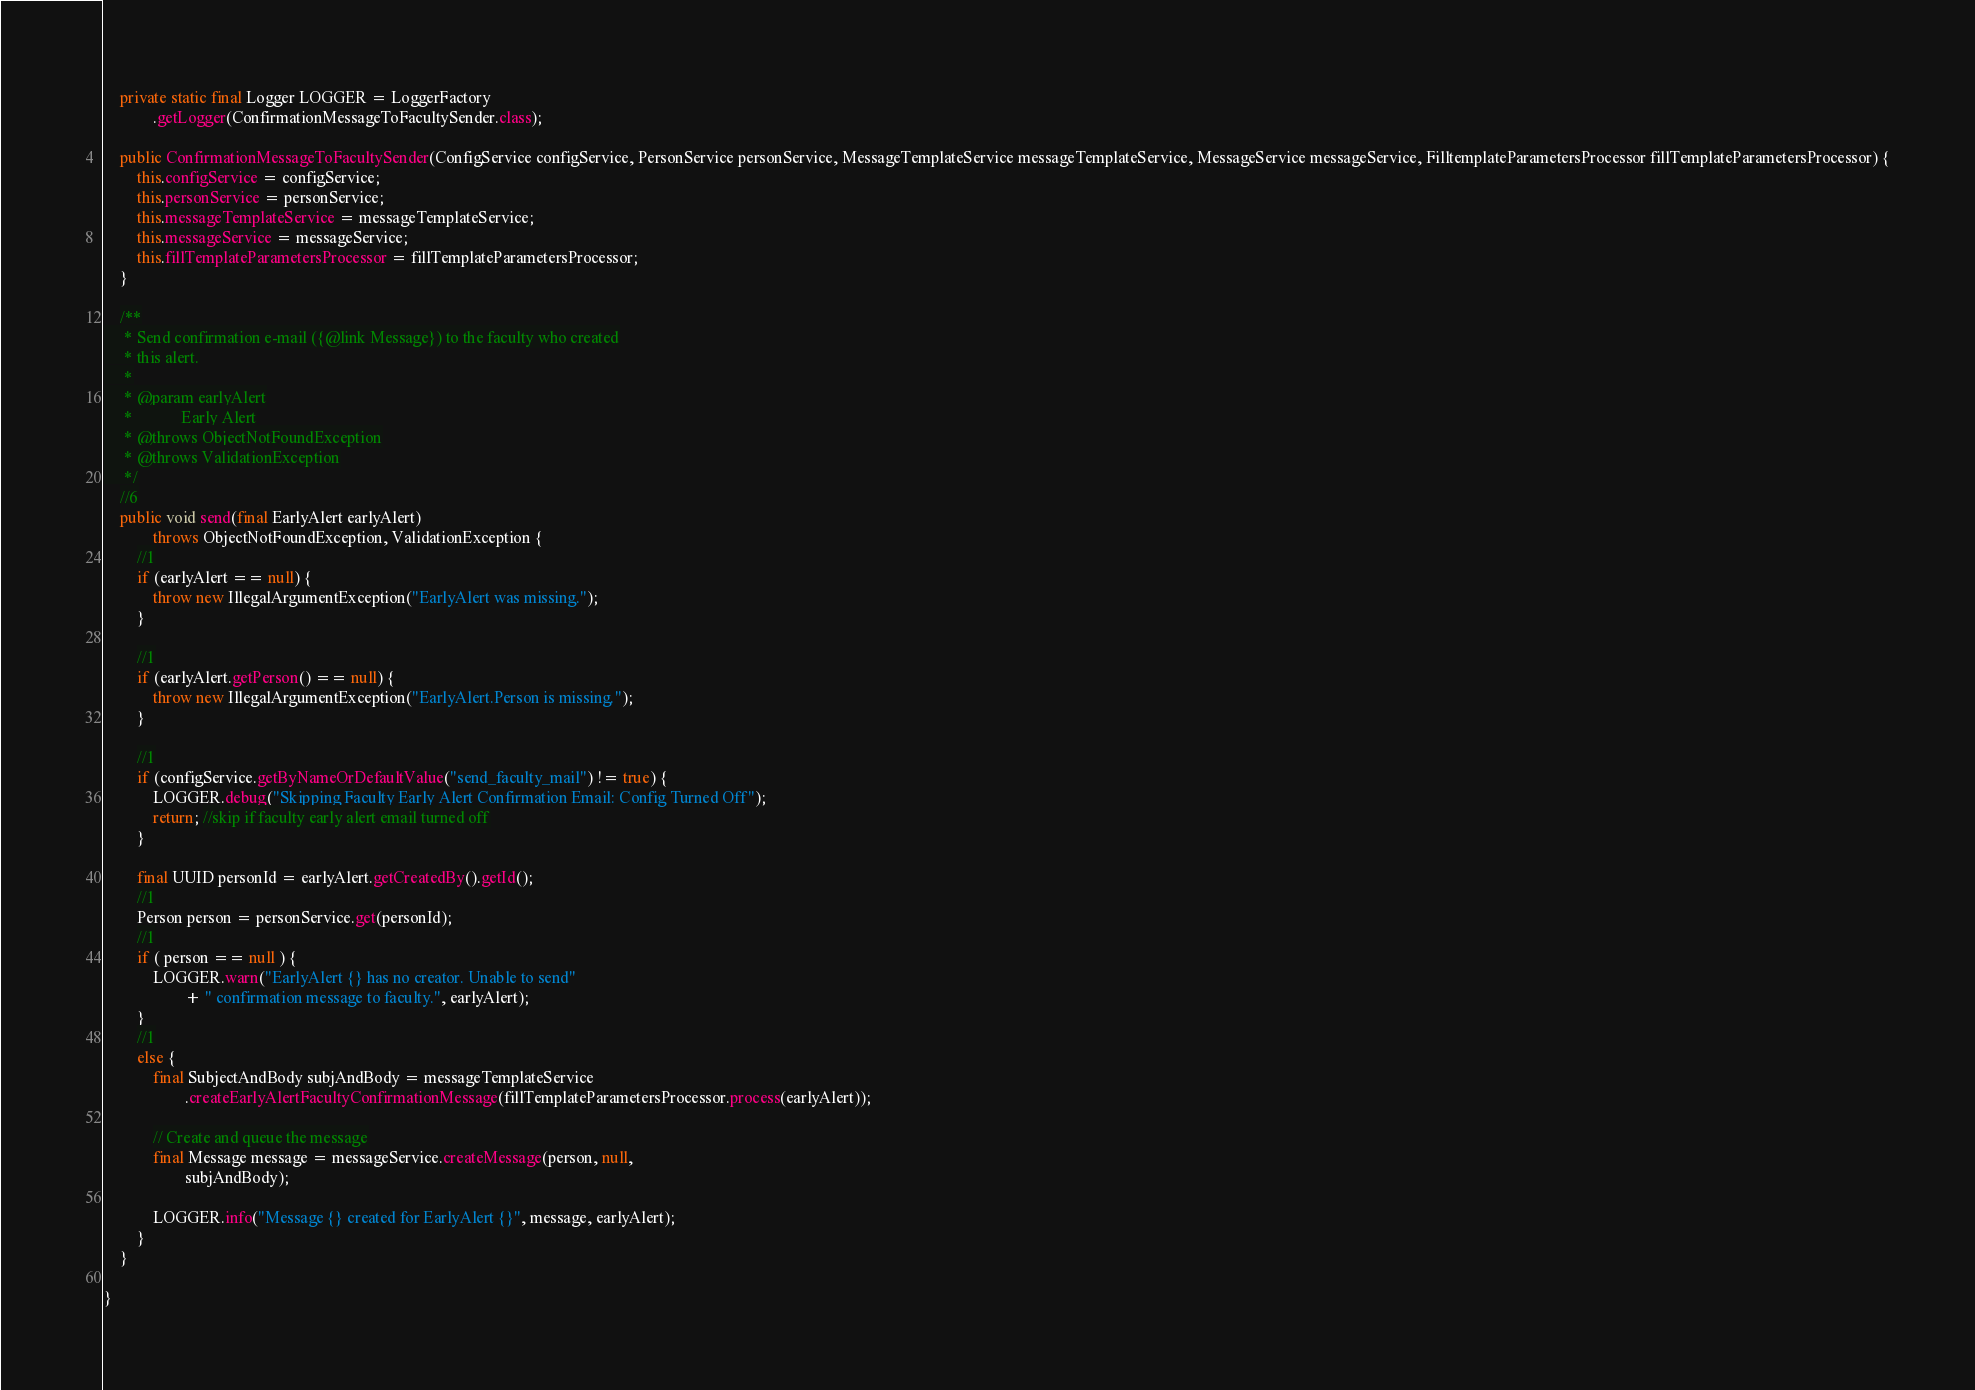Convert code to text. <code><loc_0><loc_0><loc_500><loc_500><_Java_>
    private static final Logger LOGGER = LoggerFactory
            .getLogger(ConfirmationMessageToFacultySender.class);

    public ConfirmationMessageToFacultySender(ConfigService configService, PersonService personService, MessageTemplateService messageTemplateService, MessageService messageService, FilltemplateParametersProcessor fillTemplateParametersProcessor) {
        this.configService = configService;
        this.personService = personService;
        this.messageTemplateService = messageTemplateService;
        this.messageService = messageService;
        this.fillTemplateParametersProcessor = fillTemplateParametersProcessor;
    }

    /**
     * Send confirmation e-mail ({@link Message}) to the faculty who created
     * this alert.
     *
     * @param earlyAlert
     *            Early Alert
     * @throws ObjectNotFoundException
     * @throws ValidationException
     */
    //6
    public void send(final EarlyAlert earlyAlert)
            throws ObjectNotFoundException, ValidationException {
        //1
        if (earlyAlert == null) {
            throw new IllegalArgumentException("EarlyAlert was missing.");
        }

        //1
        if (earlyAlert.getPerson() == null) {
            throw new IllegalArgumentException("EarlyAlert.Person is missing.");
        }

        //1
        if (configService.getByNameOrDefaultValue("send_faculty_mail") != true) {
            LOGGER.debug("Skipping Faculty Early Alert Confirmation Email: Config Turned Off");
            return; //skip if faculty early alert email turned off
        }

        final UUID personId = earlyAlert.getCreatedBy().getId();
        //1
        Person person = personService.get(personId);
        //1
        if ( person == null ) {
            LOGGER.warn("EarlyAlert {} has no creator. Unable to send"
                    + " confirmation message to faculty.", earlyAlert);
        }
        //1
        else {
            final SubjectAndBody subjAndBody = messageTemplateService
                    .createEarlyAlertFacultyConfirmationMessage(fillTemplateParametersProcessor.process(earlyAlert));

            // Create and queue the message
            final Message message = messageService.createMessage(person, null,
                    subjAndBody);

            LOGGER.info("Message {} created for EarlyAlert {}", message, earlyAlert);
        }
    }

}
</code> 